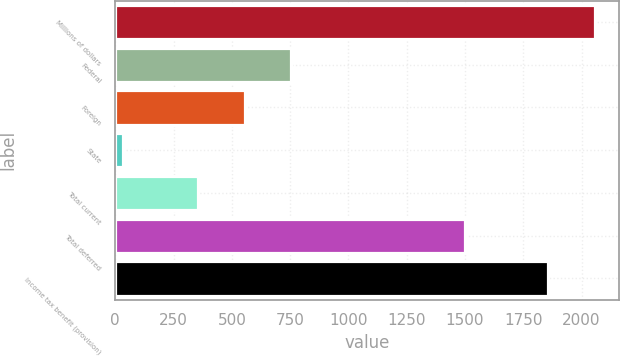Convert chart to OTSL. <chart><loc_0><loc_0><loc_500><loc_500><bar_chart><fcel>Millions of dollars<fcel>Federal<fcel>Foreign<fcel>State<fcel>Total current<fcel>Total deferred<fcel>Income tax benefit (provision)<nl><fcel>2056.1<fcel>753.2<fcel>555.1<fcel>35<fcel>357<fcel>1501<fcel>1858<nl></chart> 